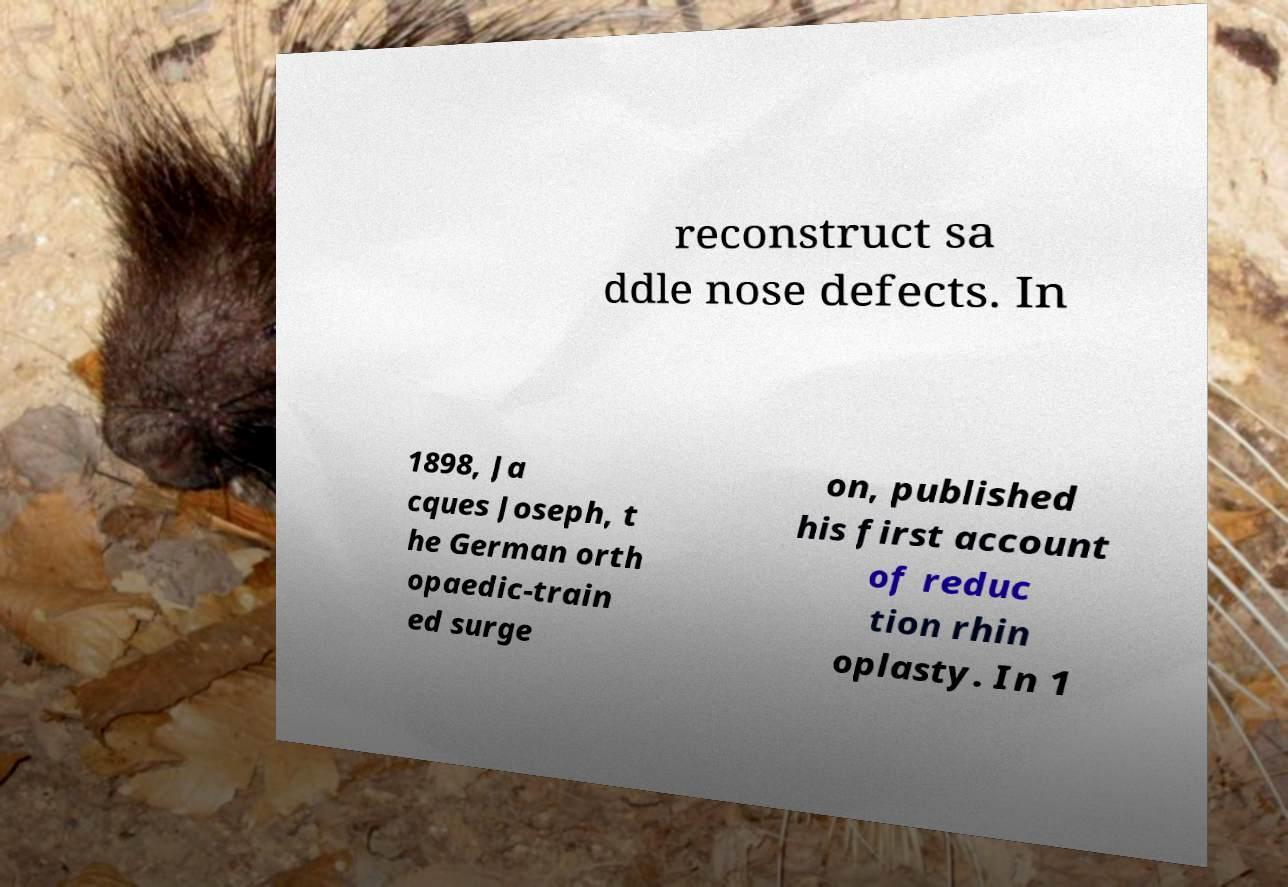Can you accurately transcribe the text from the provided image for me? reconstruct sa ddle nose defects. In 1898, Ja cques Joseph, t he German orth opaedic-train ed surge on, published his first account of reduc tion rhin oplasty. In 1 